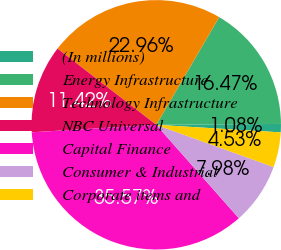Convert chart. <chart><loc_0><loc_0><loc_500><loc_500><pie_chart><fcel>(In millions)<fcel>Energy Infrastructure<fcel>Technology Infrastructure<fcel>NBC Universal<fcel>Capital Finance<fcel>Consumer & Industrial<fcel>Corporate items and<nl><fcel>1.08%<fcel>16.47%<fcel>22.96%<fcel>11.42%<fcel>35.57%<fcel>7.98%<fcel>4.53%<nl></chart> 